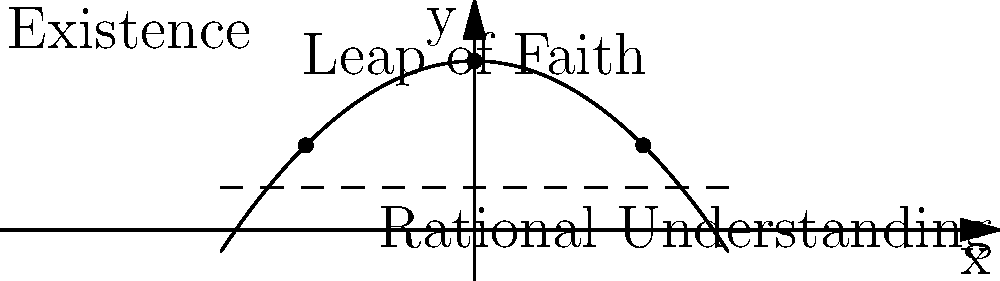In Kierkegaard's existentialism, the "leap of faith" is often represented as a discontinuous jump from rational understanding to religious belief. Using the given parabola to represent this concept, what is the equation of the parabola if the vertex represents the highest point of faith at (0, 2), and the x-intercepts at (-2, 0) and (2, 0) represent the limits of rational understanding? To find the equation of the parabola, we'll follow these steps:

1. The general form of a parabola is $f(x) = a(x-h)^2 + k$, where (h, k) is the vertex.

2. We're given that the vertex is at (0, 2), so h = 0 and k = 2.

3. Our equation now looks like: $f(x) = a(x-0)^2 + 2$ or $f(x) = ax^2 + 2$

4. We know that one x-intercept is at (2, 0). We can use this point to find 'a':

   $0 = a(2)^2 + 2$
   $-2 = 4a$
   $a = -\frac{1}{2}$

5. Therefore, the equation of our parabola is:

   $f(x) = -\frac{1}{2}x^2 + 2$

6. We can verify this equation also satisfies the other x-intercept at (-2, 0):

   $f(-2) = -\frac{1}{2}(-2)^2 + 2 = -2 + 2 = 0$

This parabola represents Kierkegaard's concept of the leap of faith, where:
- The vertex (0, 2) represents the highest point of faith.
- The x-axis represents rational understanding.
- The curve of the parabola represents the journey of faith.
- The discontinuity between rational understanding and faith is represented by the conceptual "jump" from the x-axis to a point on the curve.
Answer: $f(x) = -\frac{1}{2}x^2 + 2$ 